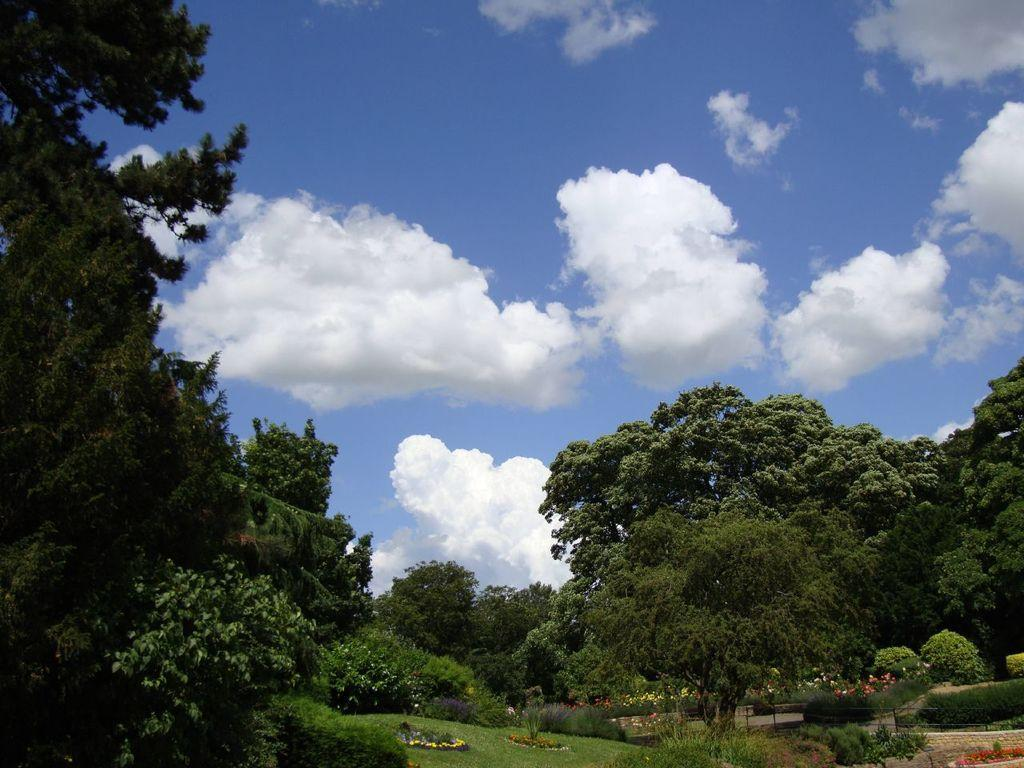What type of vegetation can be seen in the image? There are trees and plants with flowers in the image. What is on the ground in the image? There is grass on the ground in the image. What is visible at the top of the image? The sky is visible at the top of the image. What can be seen in the sky? Clouds are present in the sky. How many thumbs are visible in the image? There are no thumbs present in the image. What type of fruit can be seen growing on the trees in the image? There is no fruit visible in the image, only trees and plants with flowers. 